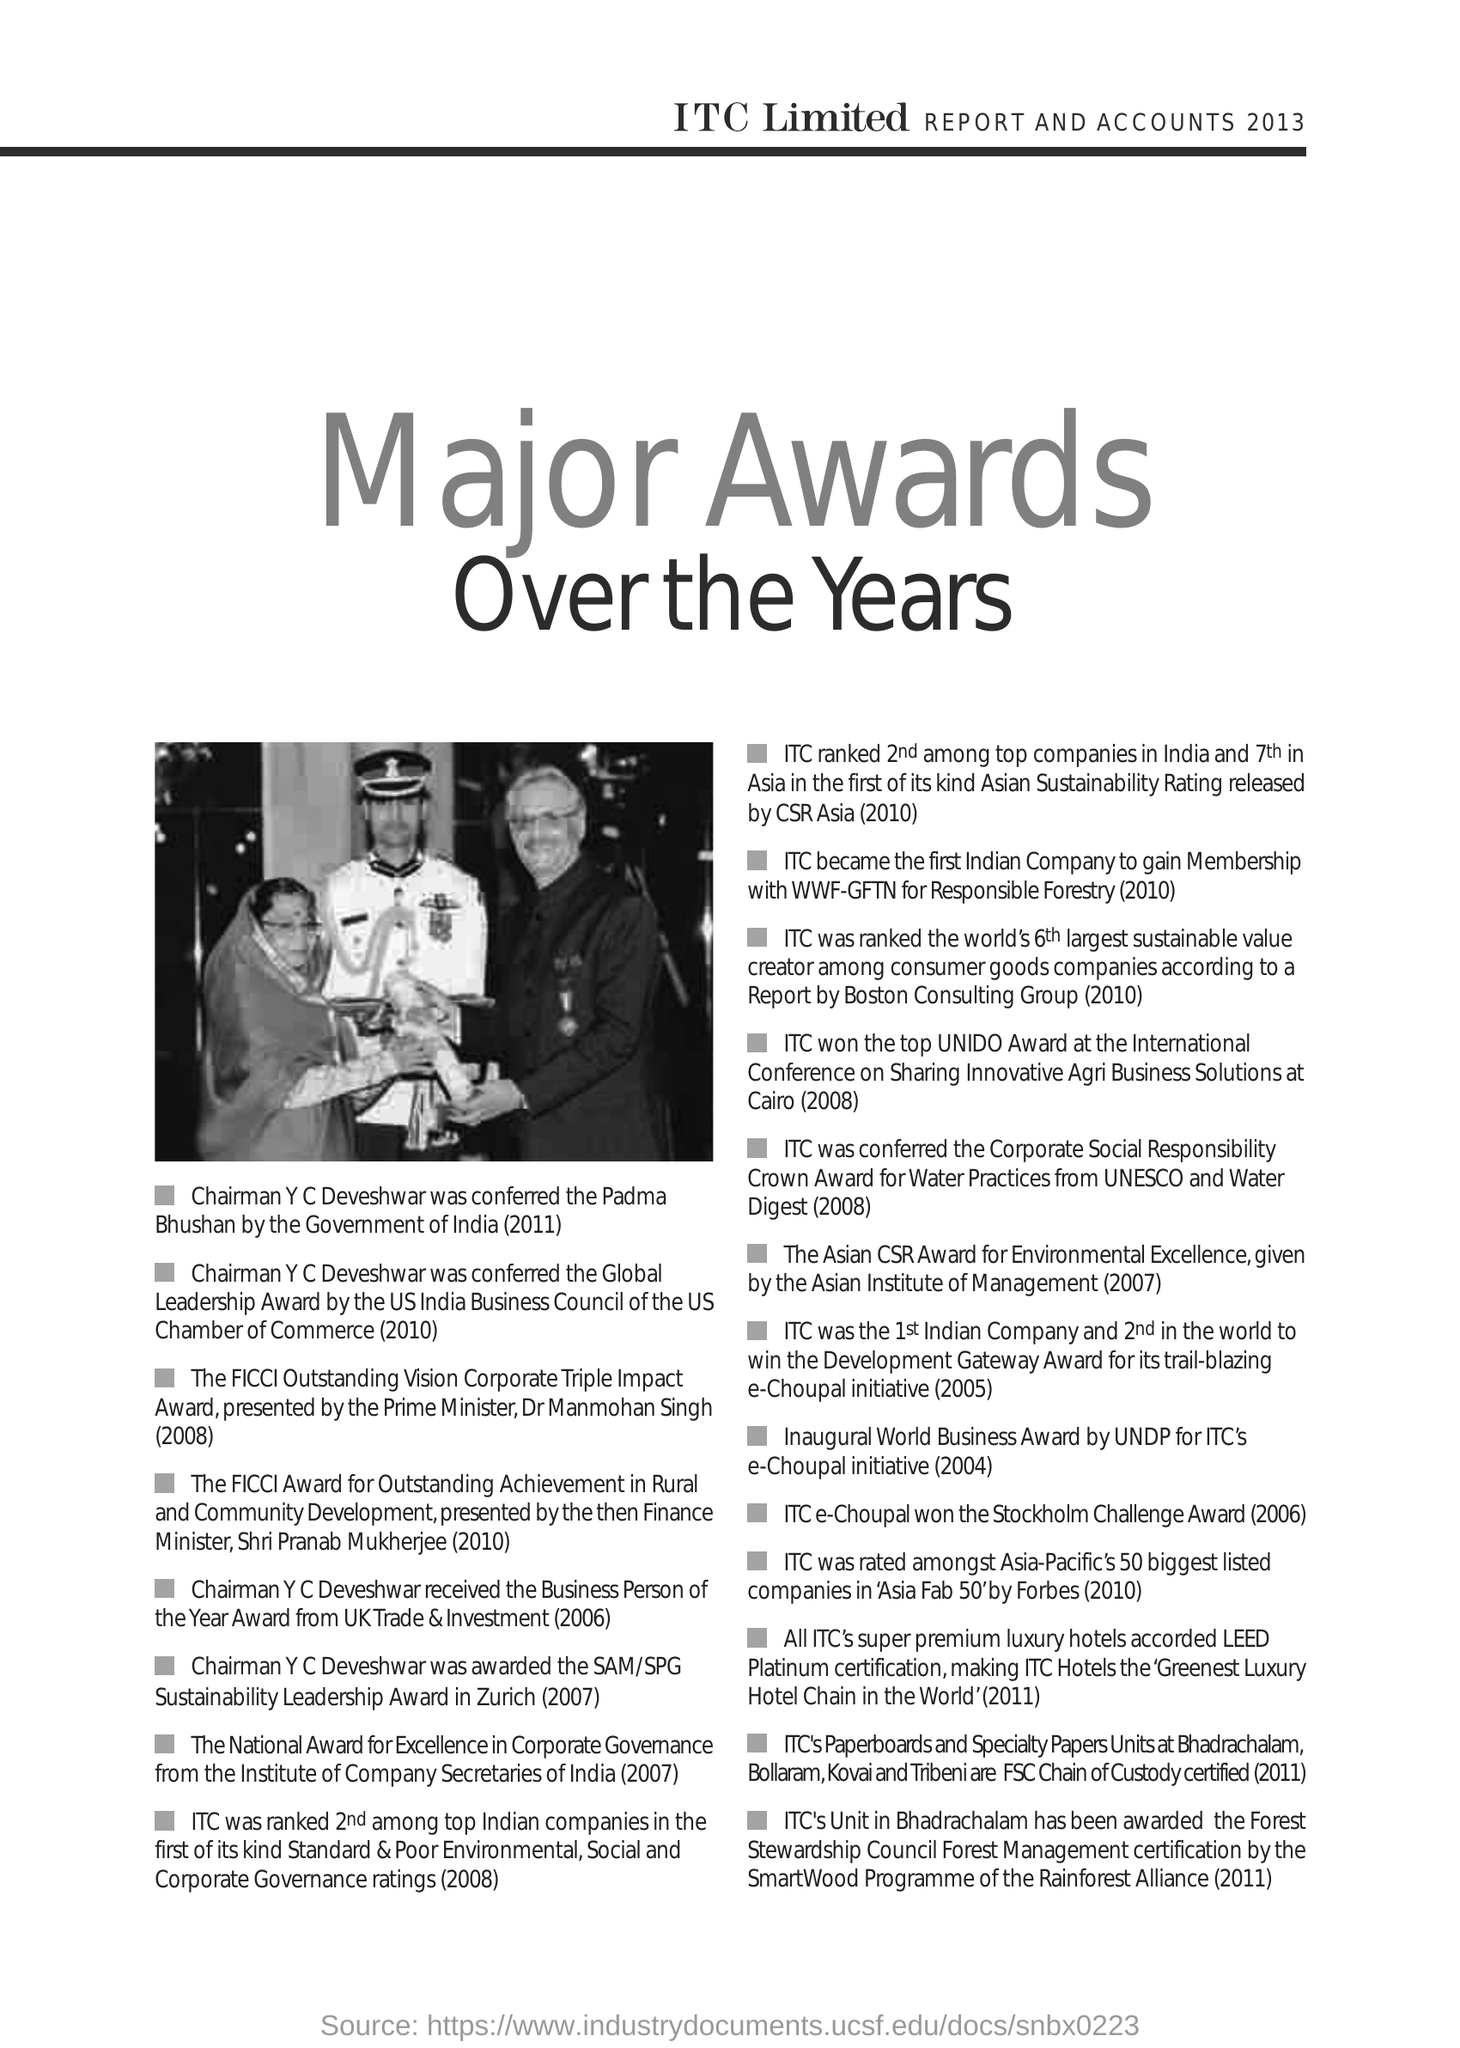Who was awarded the SAM/SPG Sustainability Leadership Award in Zurich (2007)?
Offer a very short reply. CHAIRMAN Y C DEVESHWAR. In which year ITC e-Choupal won the Stockholm Challenge Award?
Keep it short and to the point. 2006. 